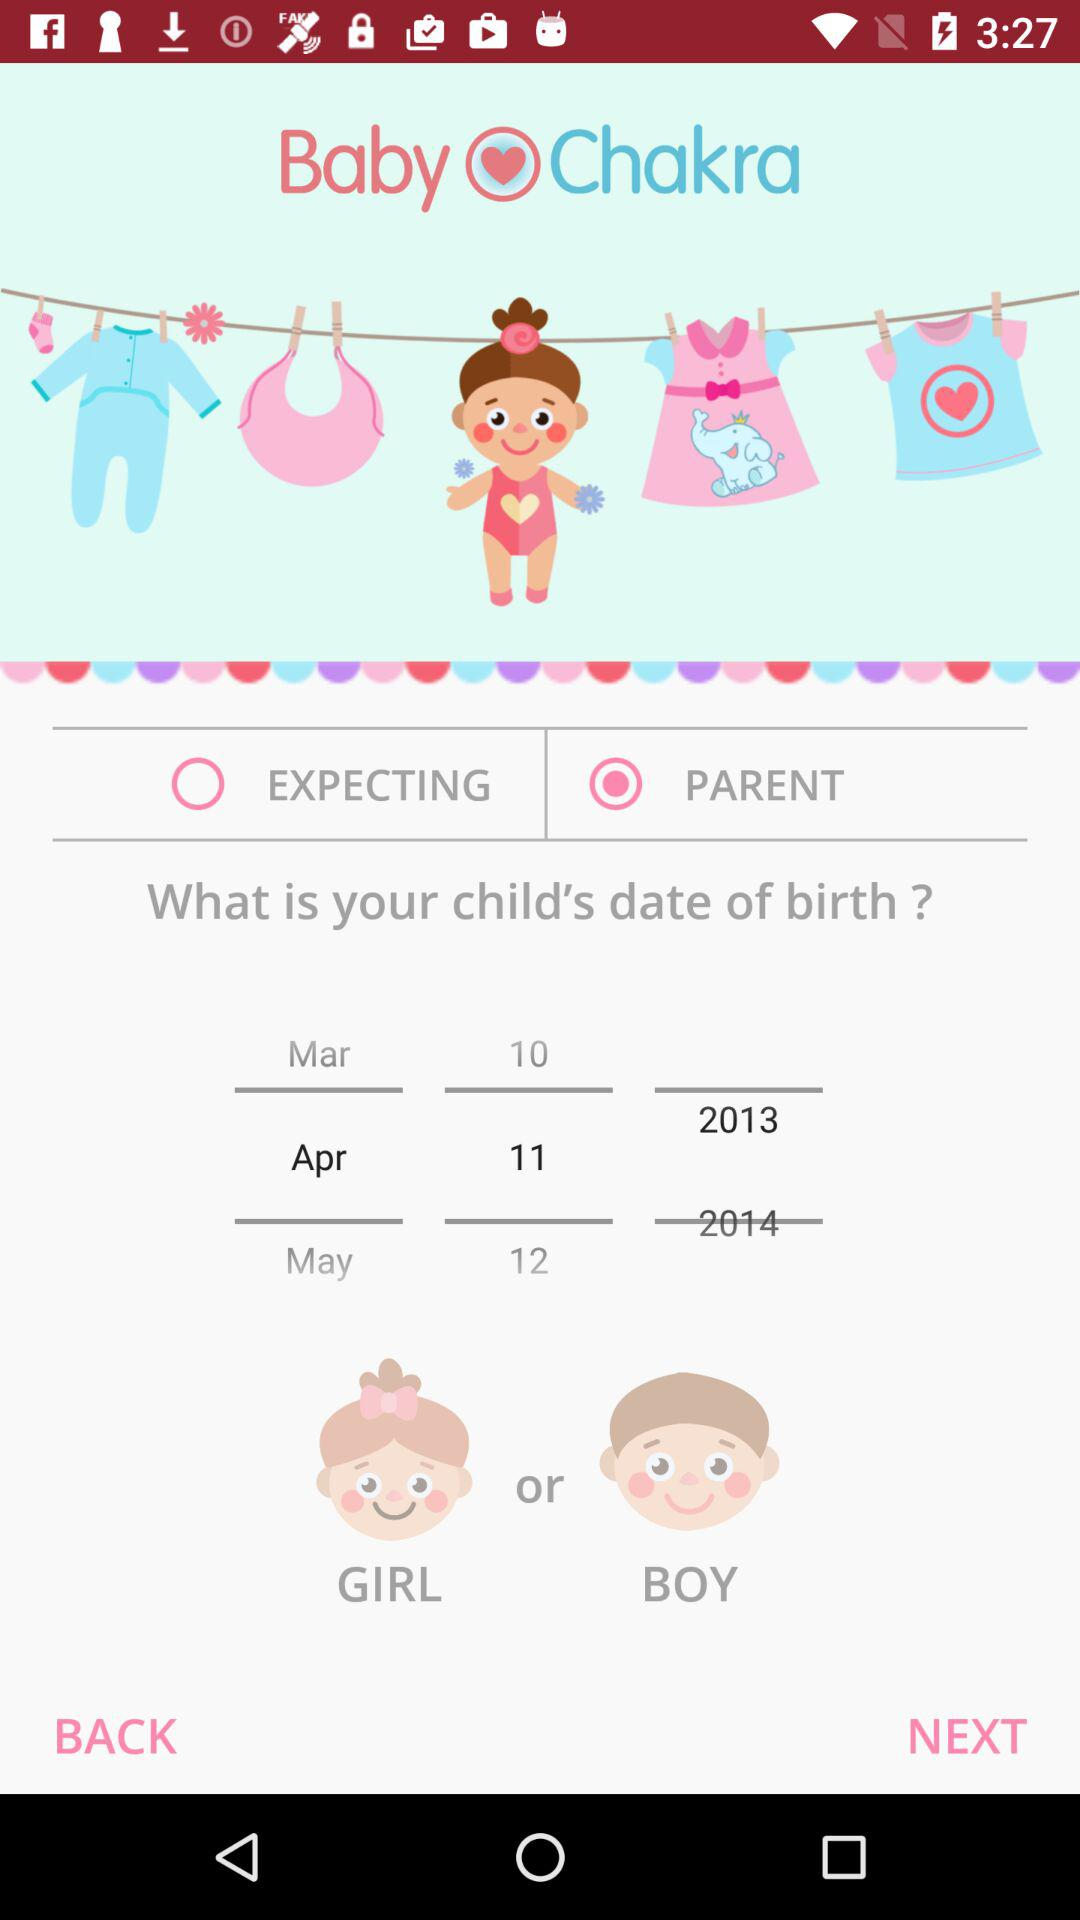What is the name of the application? The name of the application is "Baby Chakra". 